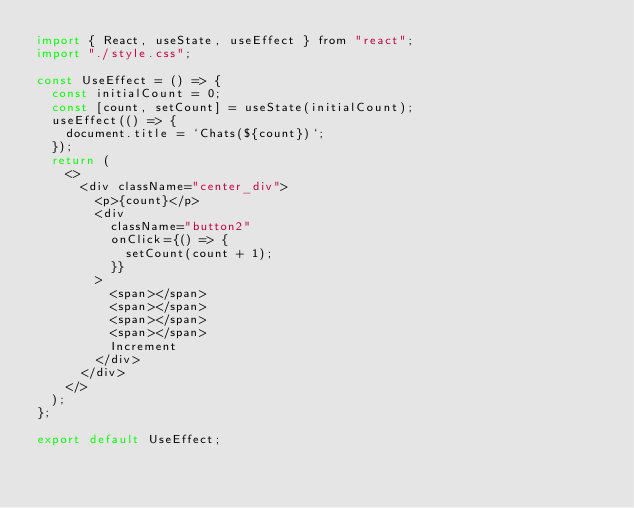<code> <loc_0><loc_0><loc_500><loc_500><_JavaScript_>import { React, useState, useEffect } from "react";
import "./style.css";

const UseEffect = () => {
  const initialCount = 0;
  const [count, setCount] = useState(initialCount);
  useEffect(() => {
    document.title = `Chats(${count})`;
  });
  return (
    <>
      <div className="center_div">
        <p>{count}</p>
        <div
          className="button2"
          onClick={() => {
            setCount(count + 1);
          }}
        >
          <span></span>
          <span></span>
          <span></span>
          <span></span>
          Increment
        </div>
      </div>
    </>
  );
};

export default UseEffect;
</code> 